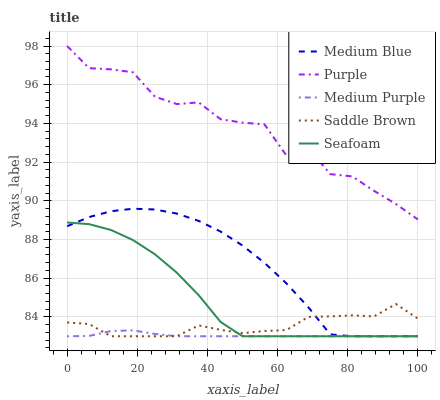Does Medium Purple have the minimum area under the curve?
Answer yes or no. Yes. Does Purple have the maximum area under the curve?
Answer yes or no. Yes. Does Medium Blue have the minimum area under the curve?
Answer yes or no. No. Does Medium Blue have the maximum area under the curve?
Answer yes or no. No. Is Medium Purple the smoothest?
Answer yes or no. Yes. Is Purple the roughest?
Answer yes or no. Yes. Is Medium Blue the smoothest?
Answer yes or no. No. Is Medium Blue the roughest?
Answer yes or no. No. Does Medium Purple have the lowest value?
Answer yes or no. Yes. Does Purple have the highest value?
Answer yes or no. Yes. Does Medium Blue have the highest value?
Answer yes or no. No. Is Medium Blue less than Purple?
Answer yes or no. Yes. Is Purple greater than Medium Blue?
Answer yes or no. Yes. Does Medium Blue intersect Saddle Brown?
Answer yes or no. Yes. Is Medium Blue less than Saddle Brown?
Answer yes or no. No. Is Medium Blue greater than Saddle Brown?
Answer yes or no. No. Does Medium Blue intersect Purple?
Answer yes or no. No. 